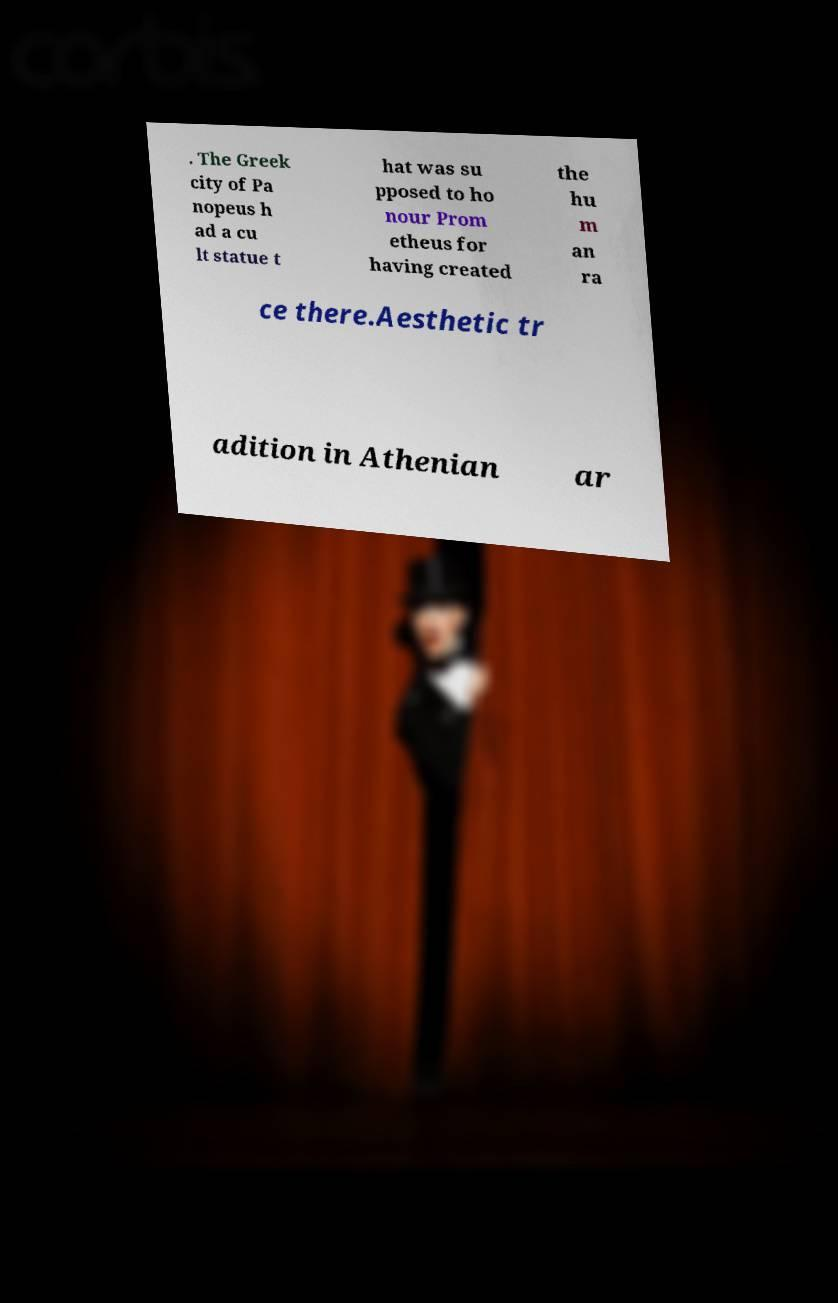Could you extract and type out the text from this image? . The Greek city of Pa nopeus h ad a cu lt statue t hat was su pposed to ho nour Prom etheus for having created the hu m an ra ce there.Aesthetic tr adition in Athenian ar 